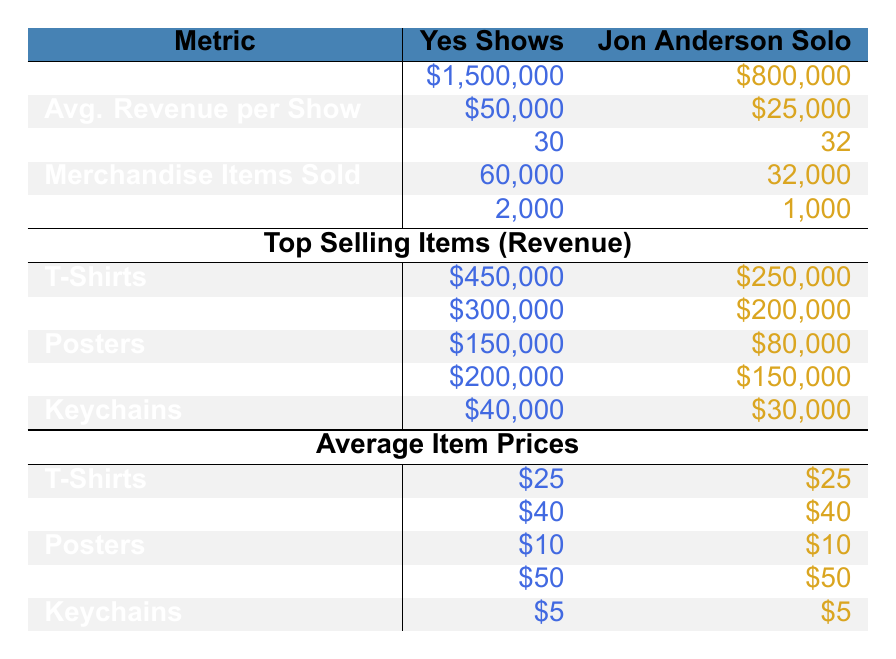What is the total revenue from merchandise sales for Yes shows? The total revenue for Yes shows is clearly stated in the table under "Total Revenue". It shows \$1,500,000.
Answer: \$1,500,000 What is the average revenue per show for Jon Anderson solo shows? The average revenue per show for Jon Anderson solo shows is listed in the "Avg. Revenue per Show" section, which shows \$25,000.
Answer: \$25,000 How many more merchandise items were sold at Yes shows compared to Jon Anderson solo shows? To find the difference in merchandise items sold, take the items sold at Yes shows (60,000) and subtract the items sold at Jon Anderson solo shows (32,000): 60,000 - 32,000 = 28,000.
Answer: 28,000 Did Yes shows sell more posters than Jon Anderson solo shows? To determine this, we look at the revenue from posters. Yes shows generated \$150,000 from posters, while Jon Anderson solo shows only generated \$80,000. Yes shows sold more posters than Jon Anderson.
Answer: Yes What is the total revenue from T-Shirts sold at Yes shows? The revenue generated from T-Shirts at Yes shows is listed in the "Top Selling Items" section as \$450,000.
Answer: \$450,000 What is the total number of shows for both Jon Anderson solo shows and Yes shows combined? To find the total number of shows, add the number of Yes shows (30) to the number of Jon Anderson solo shows (32): 30 + 32 = 62.
Answer: 62 Which merchandise item generated the most revenue for Jon Anderson solo shows? The top-selling item for Jon Anderson solo shows is T-Shirts, which generated \$250,000 according to the "Top Selling Items" section.
Answer: T-Shirts What is the average number of items sold per show for Yes shows compared to Jon Anderson solo shows? For Yes shows, the average items sold per show is shown as 2,000. For Jon Anderson solo shows, it is 1,000. Therefore, Yes shows sold twice as many items per show on average compared to Jon Anderson.
Answer: Yes shows sold twice as many What is the difference in total merchandise revenue between Yes and Jon Anderson solo shows? To find the difference in total revenue, subtract Jon Anderson’s total revenue (\$800,000) from Yes’s total revenue (\$1,500,000): 1,500,000 - 800,000 = 700,000.
Answer: \$700,000 